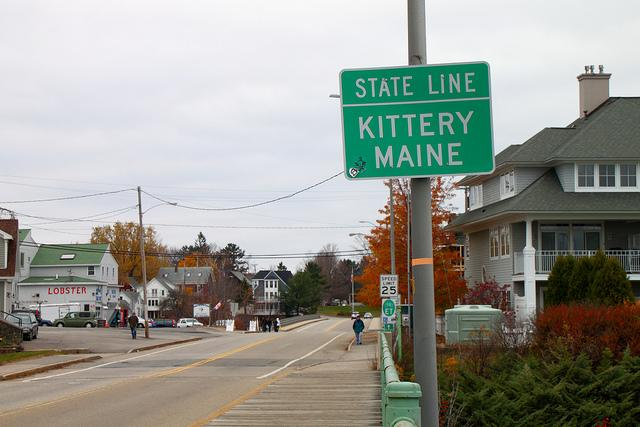What large body of water is nearest this location? ocean 